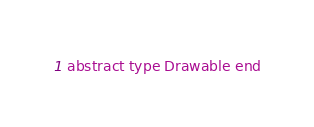<code> <loc_0><loc_0><loc_500><loc_500><_Julia_>abstract type Drawable end
</code> 